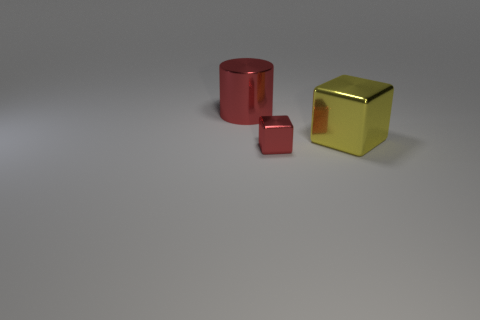Are there more red metal cylinders than gray shiny cubes?
Provide a succinct answer. Yes. What material is the thing that is the same size as the red metal cylinder?
Provide a short and direct response. Metal. Do the red object in front of the red cylinder and the big cylinder have the same size?
Ensure brevity in your answer.  No. How many cylinders are either shiny objects or tiny brown metallic things?
Your answer should be compact. 1. What material is the cube that is right of the red cube?
Make the answer very short. Metal. Is the number of large metallic objects less than the number of small cubes?
Offer a very short reply. No. There is a metallic thing that is on the right side of the large red cylinder and left of the big yellow thing; how big is it?
Keep it short and to the point. Small. There is a red metallic thing that is right of the object to the left of the metallic object in front of the large yellow metal cube; what size is it?
Give a very brief answer. Small. What number of other objects are the same color as the large cylinder?
Your response must be concise. 1. Do the shiny block that is on the left side of the yellow metallic thing and the shiny cylinder have the same color?
Your answer should be compact. Yes. 